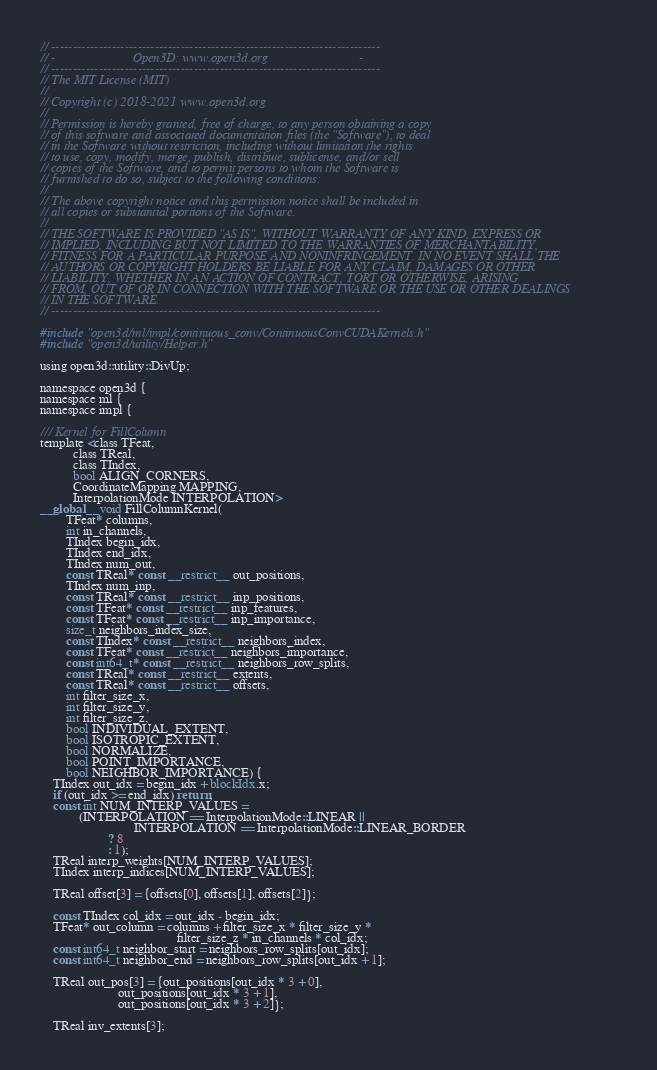Convert code to text. <code><loc_0><loc_0><loc_500><loc_500><_Cuda_>// ----------------------------------------------------------------------------
// -                        Open3D: www.open3d.org                            -
// ----------------------------------------------------------------------------
// The MIT License (MIT)
//
// Copyright (c) 2018-2021 www.open3d.org
//
// Permission is hereby granted, free of charge, to any person obtaining a copy
// of this software and associated documentation files (the "Software"), to deal
// in the Software without restriction, including without limitation the rights
// to use, copy, modify, merge, publish, distribute, sublicense, and/or sell
// copies of the Software, and to permit persons to whom the Software is
// furnished to do so, subject to the following conditions:
//
// The above copyright notice and this permission notice shall be included in
// all copies or substantial portions of the Software.
//
// THE SOFTWARE IS PROVIDED "AS IS", WITHOUT WARRANTY OF ANY KIND, EXPRESS OR
// IMPLIED, INCLUDING BUT NOT LIMITED TO THE WARRANTIES OF MERCHANTABILITY,
// FITNESS FOR A PARTICULAR PURPOSE AND NONINFRINGEMENT. IN NO EVENT SHALL THE
// AUTHORS OR COPYRIGHT HOLDERS BE LIABLE FOR ANY CLAIM, DAMAGES OR OTHER
// LIABILITY, WHETHER IN AN ACTION OF CONTRACT, TORT OR OTHERWISE, ARISING
// FROM, OUT OF OR IN CONNECTION WITH THE SOFTWARE OR THE USE OR OTHER DEALINGS
// IN THE SOFTWARE.
// ----------------------------------------------------------------------------

#include "open3d/ml/impl/continuous_conv/ContinuousConvCUDAKernels.h"
#include "open3d/utility/Helper.h"

using open3d::utility::DivUp;

namespace open3d {
namespace ml {
namespace impl {

/// Kernel for FillColumn
template <class TFeat,
          class TReal,
          class TIndex,
          bool ALIGN_CORNERS,
          CoordinateMapping MAPPING,
          InterpolationMode INTERPOLATION>
__global__ void FillColumnKernel(
        TFeat* columns,
        int in_channels,
        TIndex begin_idx,
        TIndex end_idx,
        TIndex num_out,
        const TReal* const __restrict__ out_positions,
        TIndex num_inp,
        const TReal* const __restrict__ inp_positions,
        const TFeat* const __restrict__ inp_features,
        const TFeat* const __restrict__ inp_importance,
        size_t neighbors_index_size,
        const TIndex* const __restrict__ neighbors_index,
        const TFeat* const __restrict__ neighbors_importance,
        const int64_t* const __restrict__ neighbors_row_splits,
        const TReal* const __restrict__ extents,
        const TReal* const __restrict__ offsets,
        int filter_size_x,
        int filter_size_y,
        int filter_size_z,
        bool INDIVIDUAL_EXTENT,
        bool ISOTROPIC_EXTENT,
        bool NORMALIZE,
        bool POINT_IMPORTANCE,
        bool NEIGHBOR_IMPORTANCE) {
    TIndex out_idx = begin_idx + blockIdx.x;
    if (out_idx >= end_idx) return;
    const int NUM_INTERP_VALUES =
            (INTERPOLATION == InterpolationMode::LINEAR ||
                             INTERPOLATION == InterpolationMode::LINEAR_BORDER
                     ? 8
                     : 1);
    TReal interp_weights[NUM_INTERP_VALUES];
    TIndex interp_indices[NUM_INTERP_VALUES];

    TReal offset[3] = {offsets[0], offsets[1], offsets[2]};

    const TIndex col_idx = out_idx - begin_idx;
    TFeat* out_column = columns + filter_size_x * filter_size_y *
                                          filter_size_z * in_channels * col_idx;
    const int64_t neighbor_start = neighbors_row_splits[out_idx];
    const int64_t neighbor_end = neighbors_row_splits[out_idx + 1];

    TReal out_pos[3] = {out_positions[out_idx * 3 + 0],
                        out_positions[out_idx * 3 + 1],
                        out_positions[out_idx * 3 + 2]};

    TReal inv_extents[3];</code> 